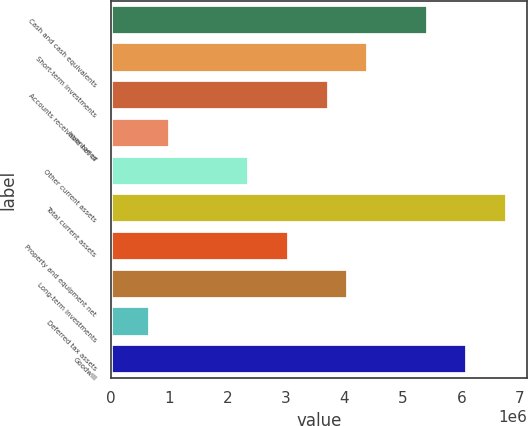<chart> <loc_0><loc_0><loc_500><loc_500><bar_chart><fcel>Cash and cash equivalents<fcel>Short-term investments<fcel>Accounts receivable net of<fcel>Inventories<fcel>Other current assets<fcel>Total current assets<fcel>Property and equipment net<fcel>Long-term investments<fcel>Deferred tax assets<fcel>Goodwill<nl><fcel>5.42425e+06<fcel>4.40726e+06<fcel>3.72927e+06<fcel>1.0173e+06<fcel>2.37329e+06<fcel>6.78024e+06<fcel>3.05128e+06<fcel>4.06827e+06<fcel>678305<fcel>6.10224e+06<nl></chart> 